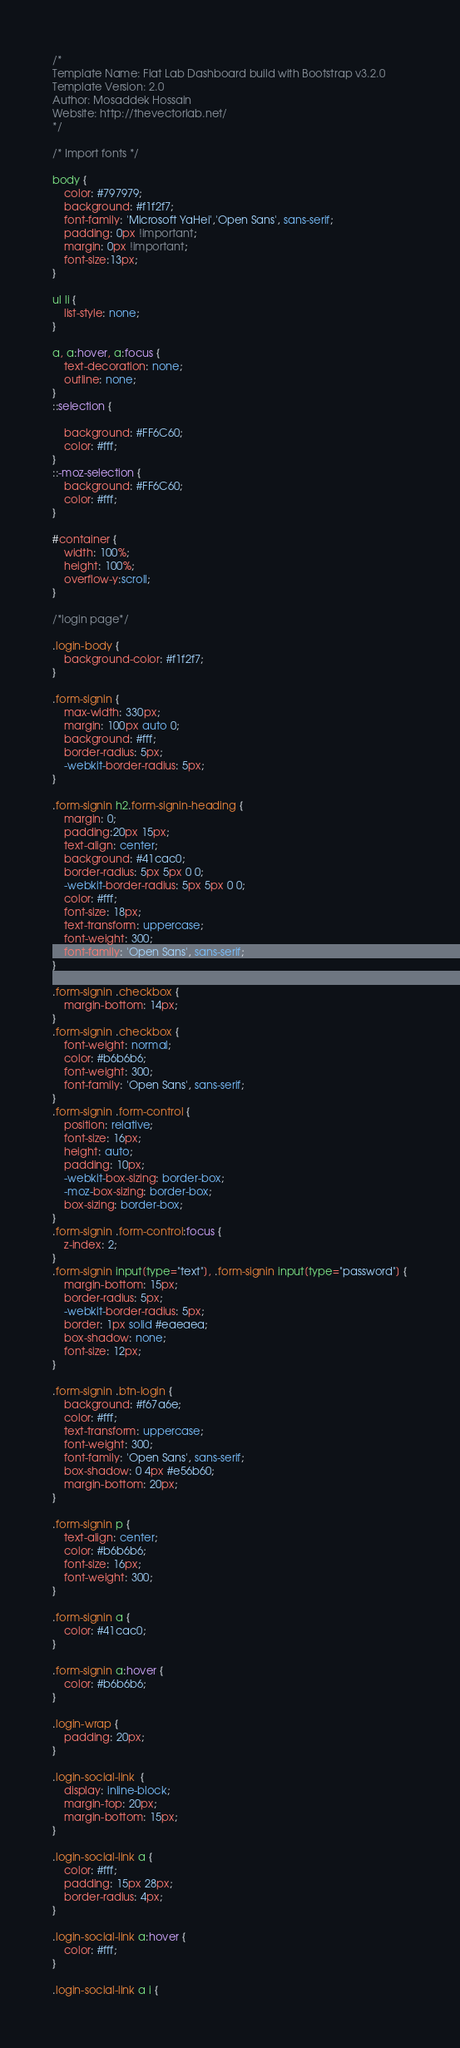<code> <loc_0><loc_0><loc_500><loc_500><_CSS_>/*
Template Name: Flat Lab Dashboard build with Bootstrap v3.2.0
Template Version: 2.0
Author: Mosaddek Hossain
Website: http://thevectorlab.net/
*/

/* Import fonts */

body {
    color: #797979;
    background: #f1f2f7;
    font-family: 'Microsoft YaHei','Open Sans', sans-serif;
    padding: 0px !important;
    margin: 0px !important;
    font-size:13px;
}

ul li {
    list-style: none;
}

a, a:hover, a:focus {
    text-decoration: none;
    outline: none;
}
::selection {

    background: #FF6C60;
    color: #fff;
}
::-moz-selection {
    background: #FF6C60;
    color: #fff;
}

#container {
    width: 100%;
    height: 100%;
    overflow-y:scroll;
}

/*login page*/

.login-body {
    background-color: #f1f2f7;
}

.form-signin {
    max-width: 330px;
    margin: 100px auto 0;
    background: #fff;
    border-radius: 5px;
    -webkit-border-radius: 5px;
}

.form-signin h2.form-signin-heading {
    margin: 0;
    padding:20px 15px;
    text-align: center;
    background: #41cac0;
    border-radius: 5px 5px 0 0;
    -webkit-border-radius: 5px 5px 0 0;
    color: #fff;
    font-size: 18px;
    text-transform: uppercase;
    font-weight: 300;
    font-family: 'Open Sans', sans-serif;
}

.form-signin .checkbox {
    margin-bottom: 14px;
}
.form-signin .checkbox {
    font-weight: normal;
    color: #b6b6b6;
    font-weight: 300;
    font-family: 'Open Sans', sans-serif;
}
.form-signin .form-control {
    position: relative;
    font-size: 16px;
    height: auto;
    padding: 10px;
    -webkit-box-sizing: border-box;
    -moz-box-sizing: border-box;
    box-sizing: border-box;
}
.form-signin .form-control:focus {
    z-index: 2;
}
.form-signin input[type="text"], .form-signin input[type="password"] {
    margin-bottom: 15px;
    border-radius: 5px;
    -webkit-border-radius: 5px;
    border: 1px solid #eaeaea;
    box-shadow: none;
    font-size: 12px;
}

.form-signin .btn-login {
    background: #f67a6e;
    color: #fff;
    text-transform: uppercase;
    font-weight: 300;
    font-family: 'Open Sans', sans-serif;
    box-shadow: 0 4px #e56b60;
    margin-bottom: 20px;
}

.form-signin p {
    text-align: center;
    color: #b6b6b6;
    font-size: 16px;
    font-weight: 300;
}

.form-signin a {
    color: #41cac0;
}

.form-signin a:hover {
    color: #b6b6b6;
}

.login-wrap {
    padding: 20px;
}

.login-social-link  {
    display: inline-block;
    margin-top: 20px;
    margin-bottom: 15px;
}

.login-social-link a {
    color: #fff;
    padding: 15px 28px;
    border-radius: 4px;
}

.login-social-link a:hover {
    color: #fff;
}

.login-social-link a i {</code> 